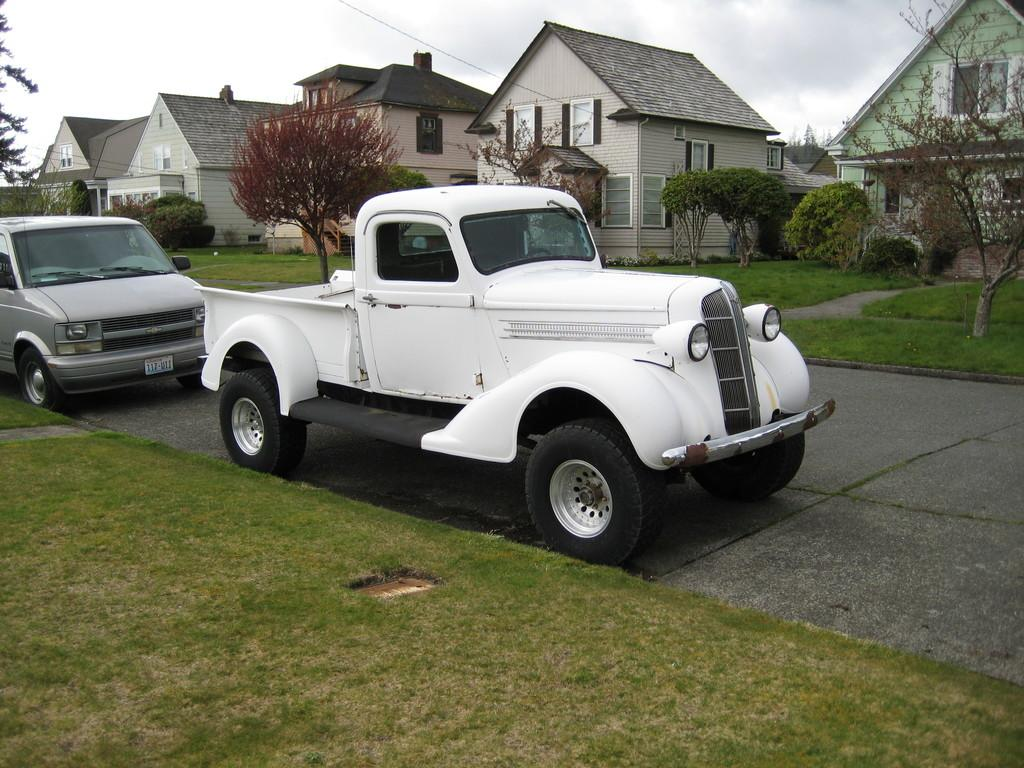What is visible on the ground in the image? The ground is visible in the image, and there are vehicles on it. What type of vegetation can be seen in the image? There is grass in the image, and there are also trees. What structures are present in the image? There are buildings in the image. What is visible in the background of the image? The sky is visible in the background of the image. What type of cord is being used for reading in the image? There is no cord or reading material present in the image. What type of skin condition can be seen on the trees in the image? There is no mention of any skin condition on the trees in the image; they appear to be healthy. 